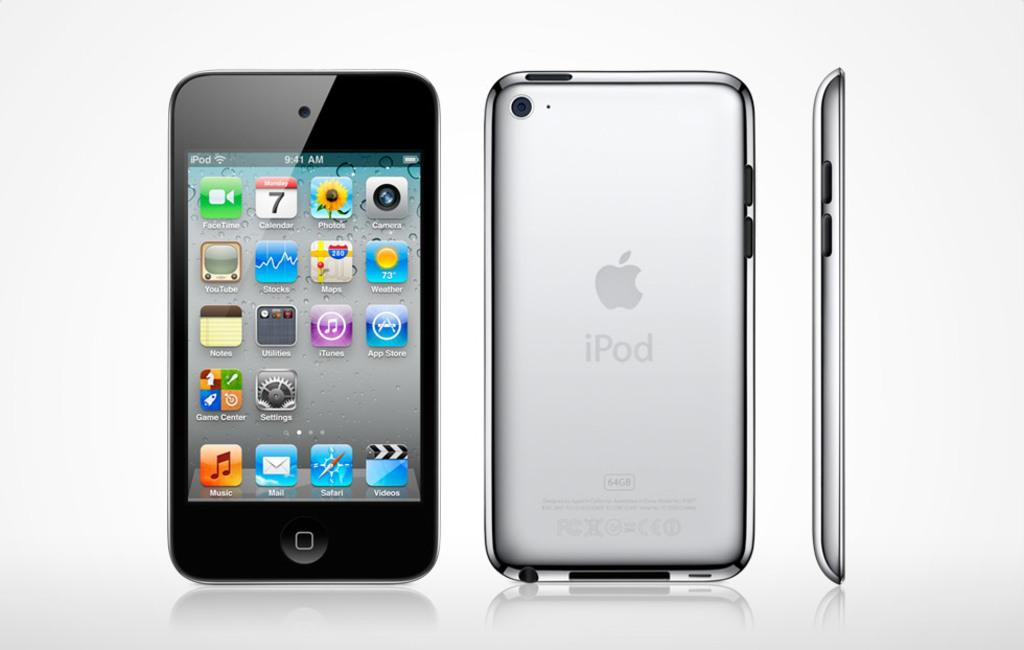<image>
Render a clear and concise summary of the photo. Displaying a version of the Apple Ipod front and back 